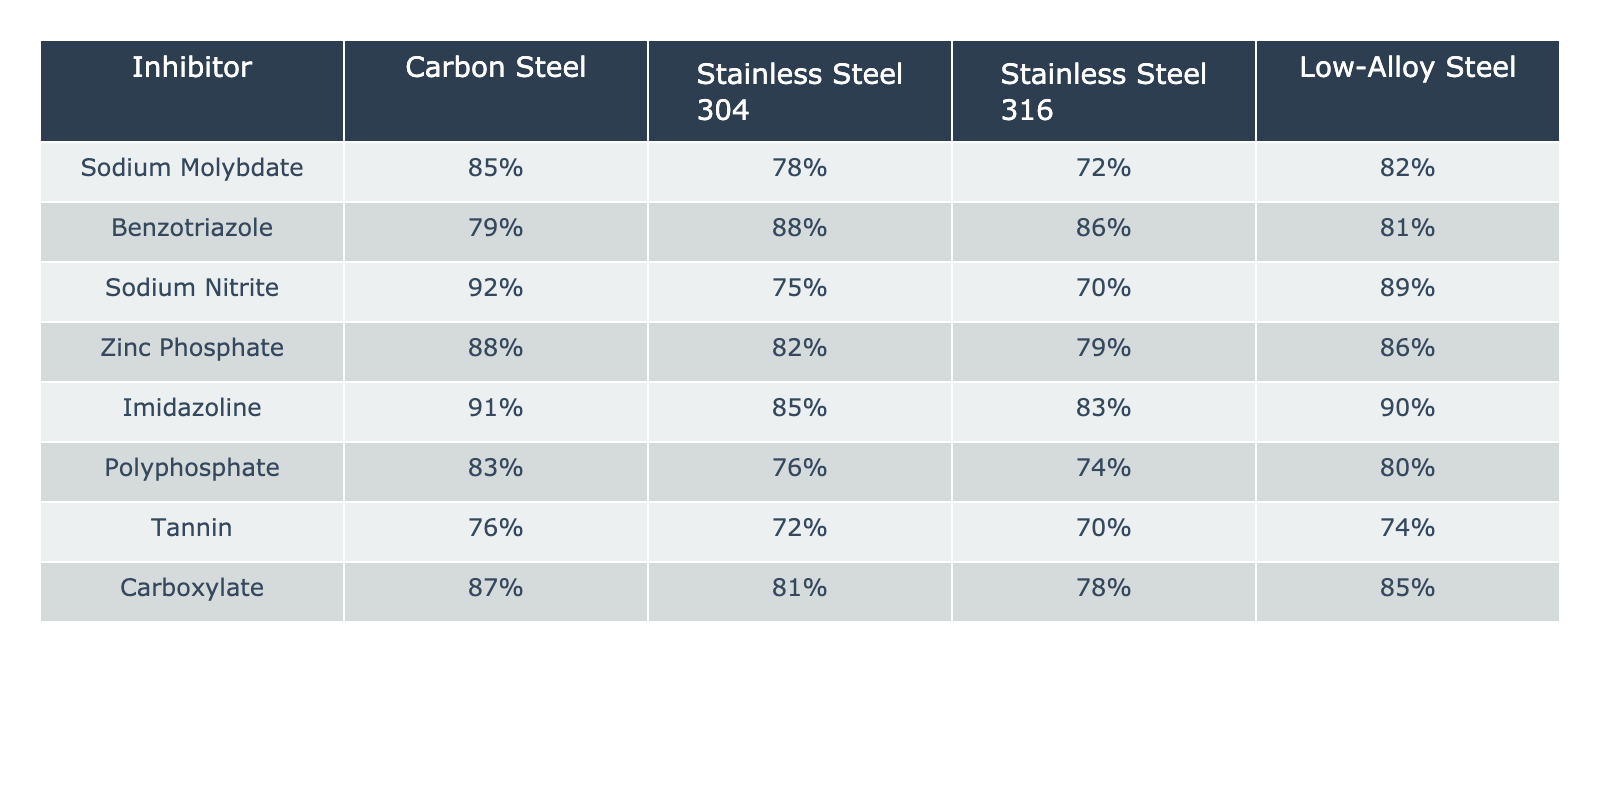What is the effectiveness percentage of Sodium Molybdate for Low-Alloy Steel? The table shows that Sodium Molybdate has an effectiveness percentage of 82% for Low-Alloy Steel.
Answer: 82% Which inhibitor is most effective for Stainless Steel 304? According to the table, Benzotriazole has the highest effectiveness percentage of 88% for Stainless Steel 304.
Answer: Benzotriazole What is the average effectiveness percentage of all inhibitors for Carbon Steel? Summing the effectiveness percentages for Carbon Steel: (85 + 79 + 92 + 88 + 91 + 83 + 76 + 87) =  701, there are 8 inhibitors, so the average is 701/8 = 87.625, rounded to 88%.
Answer: 88% Is Tannin more effective than Carboxylate for Stainless Steel 316? For Stainless Steel 316, Tannin shows 70% effectiveness while Carboxylate shows 78% effectiveness, meaning Carboxylate is more effective than Tannin.
Answer: No What is the difference in effectiveness between Sodium Nitrite for Low-Alloy Steel and Stainless Steel 304? Sodium Nitrite has an effectiveness of 89% for Low-Alloy Steel and 75% for Stainless Steel 304. The difference is 89% - 75% = 14%.
Answer: 14% Which inhibitor is the least effective for Carbon Steel? Looking at the effectiveness percentages for Carbon Steel, Tannin has the lowest value of 76%, making it the least effective.
Answer: Tannin Is Zinc Phosphate more effective than Imidazoline for Stainless Steel 316? The table indicates that Zinc Phosphate has an effectiveness of 79% while Imidazoline has 83% for Stainless Steel 316, meaning Imidazoline is more effective.
Answer: No What is the sum of effectiveness percentages for all inhibitors on Low-Alloy Steel? The effectiveness percentages for Low-Alloy Steel are: 82%, 81%, 89%, 86%, 90%, 80%, 74%, 85%. Summing these values gives us: 82 + 81 + 89 + 86 + 90 + 80 + 74 + 85 =  577%.
Answer: 577% 